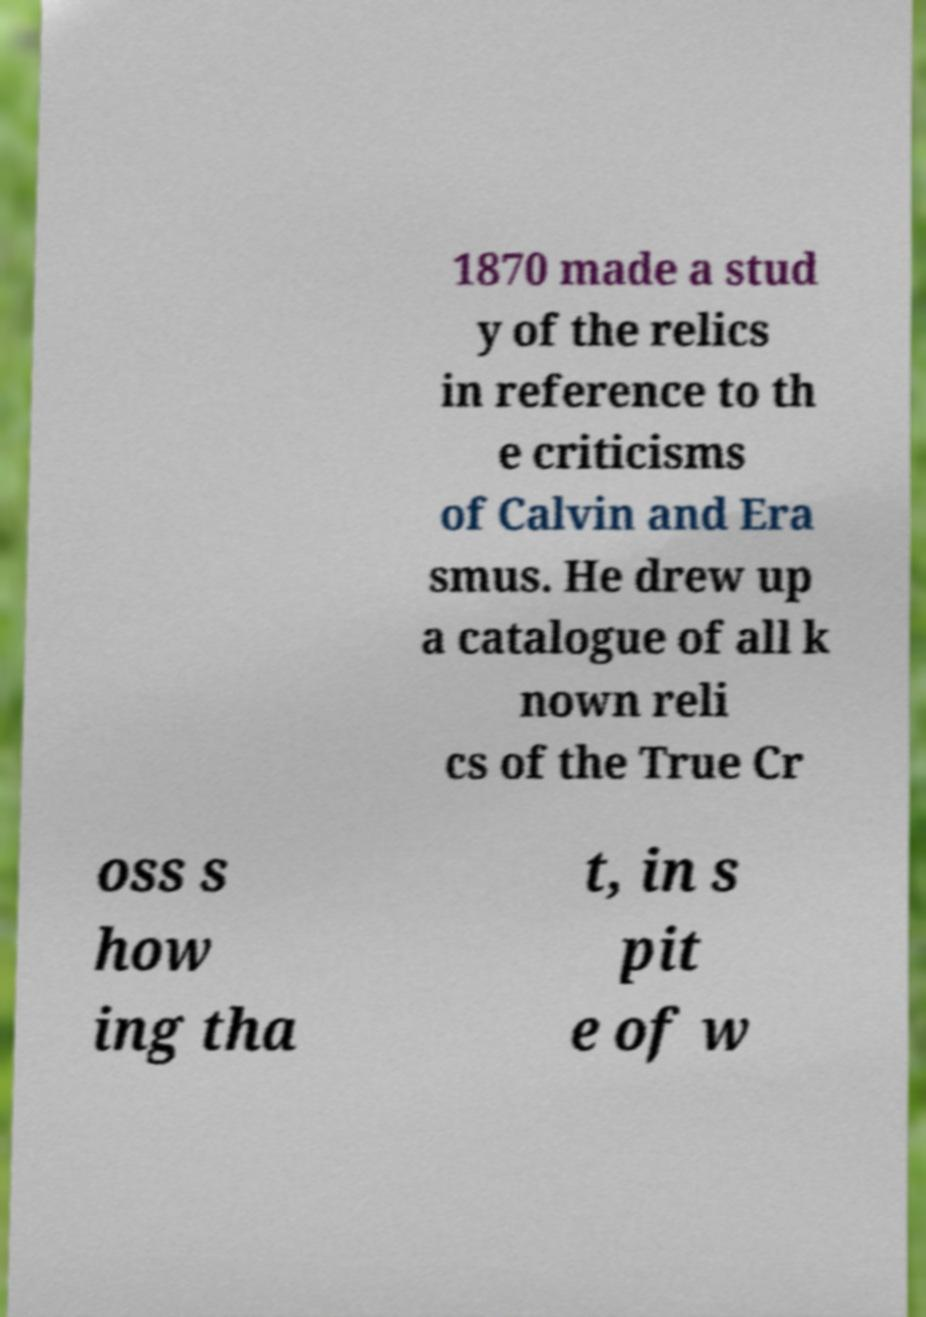What messages or text are displayed in this image? I need them in a readable, typed format. 1870 made a stud y of the relics in reference to th e criticisms of Calvin and Era smus. He drew up a catalogue of all k nown reli cs of the True Cr oss s how ing tha t, in s pit e of w 